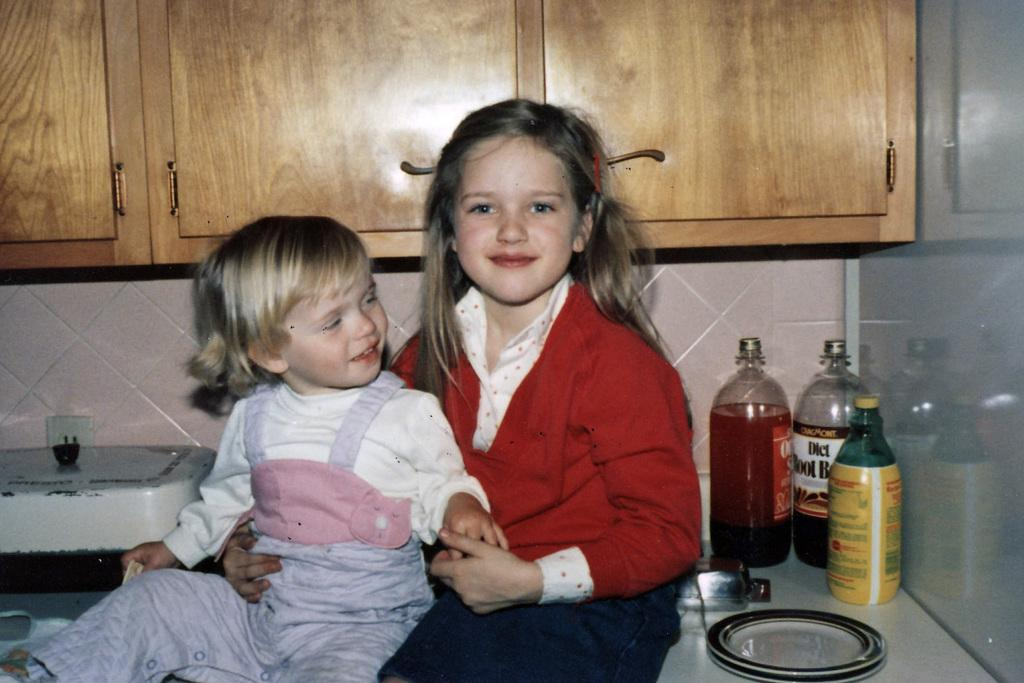<image>
Write a terse but informative summary of the picture. Bottles sit next to children on a counter, one is Diet Root Beer 